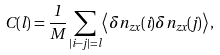<formula> <loc_0><loc_0><loc_500><loc_500>C ( l ) = \frac { 1 } { M } \sum _ { | i - j | = l } \left \langle \delta n _ { z x } ( i ) \delta n _ { z x } ( j ) \right \rangle ,</formula> 